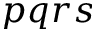<formula> <loc_0><loc_0><loc_500><loc_500>p q r s</formula> 